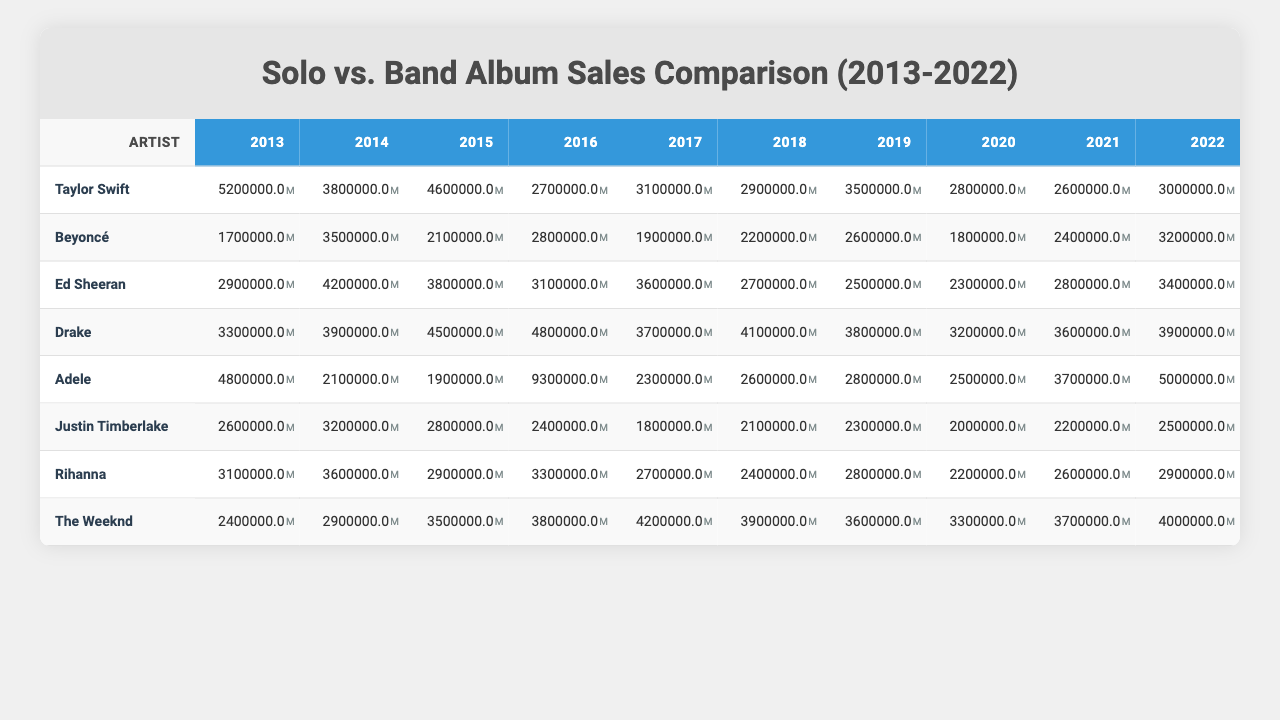What was the highest solo album sales figure recorded by Taylor Swift? In the table, Taylor Swift's solo album sales figures are listed for multiple years. The highest figure among these is 5,200,000, recorded in 2013.
Answer: 5,200,000 Which year had the lowest band album sales for Drake? By inspecting the sales data for Drake, the lowest figure is 3,200,000, which occurred in 2020.
Answer: 3,200,000 What was the total solo album sales for Rihanna from 2013 to 2022? To find the total solo album sales for Rihanna, add each year's sales: 3,100,000 + 3,600,000 + 2,900,000 + 3,300,000 + 2,700,000 + 2,400,000 + 2,800,000 + 2,200,000 + 2,600,000 + 2,900,000 = 28,700,000.
Answer: 28,700,000 Which artist had the highest total solo album sales over the decade? By calculating the total sales for each artist and comparing the sums, Taylor Swift has the highest total of 29,400,000 (5,200,000 + 3,800,000 + 4,600,000 + 2,700,000 + 3,100,000 + 2,900,000 + 3,500,000 + 2,800,000 + 2,600,000 + 3,000,000).
Answer: Taylor Swift Was Adele's band album sales ever higher than her solo album sales in any year? By comparing the sales for both solo and band albums year by year, Adele's band album sales peaked at 9,300,000 in 2016, which is higher than her solo album sales in that year (2,300,000). Thus, she did not have higher band sales compared to solo in any year.
Answer: No In which year did Ed Sheeran have his highest solo album sales? Checking Ed Sheeran's sales data, the highest solo album sales were in 2014, with a figure of 4,200,000.
Answer: 4,200,000 Calculate the average band album sales for all artists in 2021. To find the average for all artists in 2021, add the band sales for that year (2,400,000 for Taylor Swift, 3,200,000 for Beyoncé, 2,800,000 for Ed Sheeran, 3,600,000 for Drake, 3,700,000 for Adele, 2,200,000 for Justin Timberlake, 2,600,000 for Rihanna, and 3,700,000 for The Weeknd, giving a total of 24,700,000), then divide by the number of artists (8): 24,700,000 / 8 = 3,087,500.
Answer: 3,087,500 Did any artist's solo album sales decline consistently over the decade? Evaluating individual artists' solo album sales data year by year, no artist showed consistent decline every year; for instance, while some may have had decreases in certain years, all exhibited fluctuations rather than a steady decline.
Answer: No 